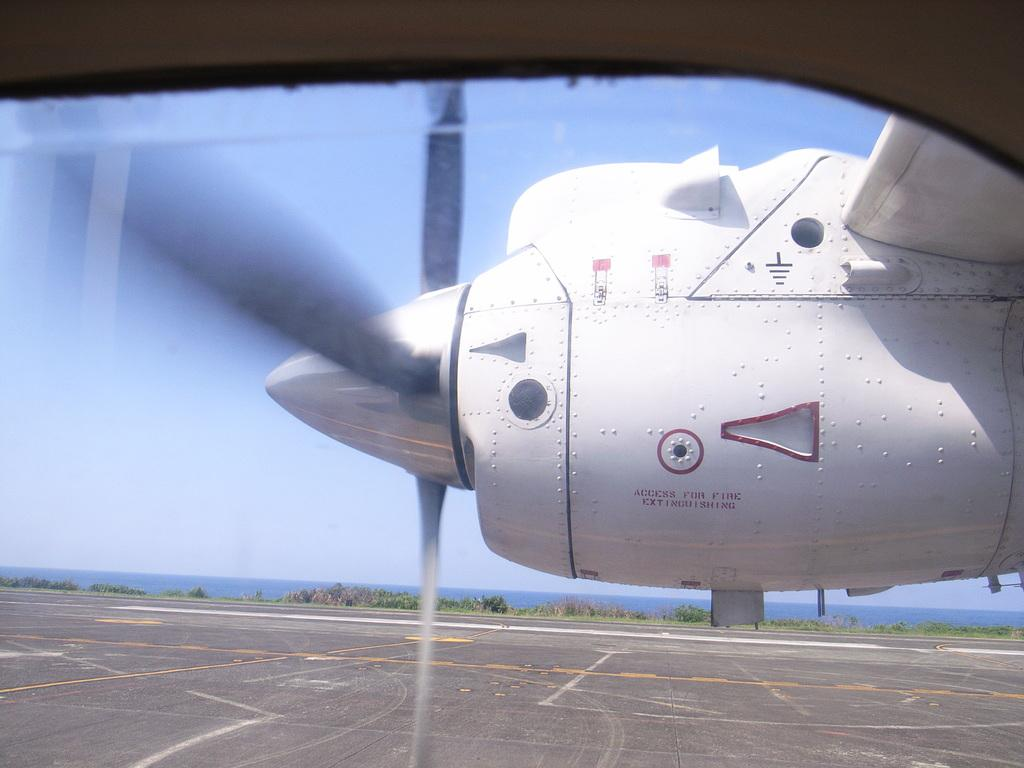What is the main subject of the image? The main subject of the image is an airplane on the runway. What else can be seen in the image besides the airplane? Plants and water are visible in the image. What is visible in the background of the image? The sky is visible in the background of the image. What type of company is responsible for the debt in the image? There is no mention of debt or a company in the image, so it cannot be determined from the image. 